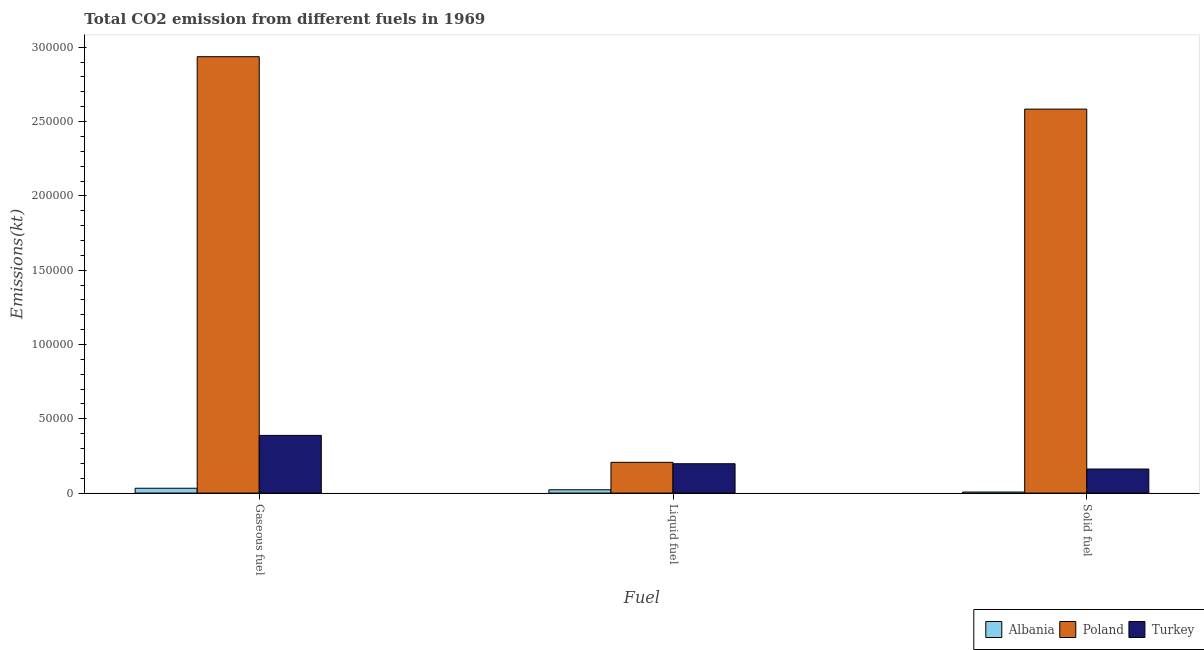Are the number of bars on each tick of the X-axis equal?
Your response must be concise. Yes. What is the label of the 2nd group of bars from the left?
Provide a succinct answer. Liquid fuel. What is the amount of co2 emissions from liquid fuel in Albania?
Give a very brief answer. 2222.2. Across all countries, what is the maximum amount of co2 emissions from solid fuel?
Keep it short and to the point. 2.58e+05. Across all countries, what is the minimum amount of co2 emissions from gaseous fuel?
Your answer should be compact. 3245.3. In which country was the amount of co2 emissions from solid fuel minimum?
Give a very brief answer. Albania. What is the total amount of co2 emissions from gaseous fuel in the graph?
Provide a short and direct response. 3.36e+05. What is the difference between the amount of co2 emissions from liquid fuel in Albania and that in Turkey?
Offer a very short reply. -1.75e+04. What is the difference between the amount of co2 emissions from liquid fuel in Poland and the amount of co2 emissions from gaseous fuel in Turkey?
Your answer should be compact. -1.81e+04. What is the average amount of co2 emissions from gaseous fuel per country?
Your answer should be compact. 1.12e+05. What is the difference between the amount of co2 emissions from gaseous fuel and amount of co2 emissions from liquid fuel in Poland?
Ensure brevity in your answer.  2.73e+05. In how many countries, is the amount of co2 emissions from liquid fuel greater than 120000 kt?
Offer a very short reply. 0. What is the ratio of the amount of co2 emissions from gaseous fuel in Poland to that in Turkey?
Provide a succinct answer. 7.57. Is the difference between the amount of co2 emissions from solid fuel in Albania and Poland greater than the difference between the amount of co2 emissions from liquid fuel in Albania and Poland?
Make the answer very short. No. What is the difference between the highest and the second highest amount of co2 emissions from gaseous fuel?
Your answer should be very brief. 2.55e+05. What is the difference between the highest and the lowest amount of co2 emissions from solid fuel?
Your answer should be compact. 2.58e+05. In how many countries, is the amount of co2 emissions from gaseous fuel greater than the average amount of co2 emissions from gaseous fuel taken over all countries?
Provide a short and direct response. 1. What does the 2nd bar from the left in Gaseous fuel represents?
Make the answer very short. Poland. What does the 3rd bar from the right in Solid fuel represents?
Offer a very short reply. Albania. Is it the case that in every country, the sum of the amount of co2 emissions from gaseous fuel and amount of co2 emissions from liquid fuel is greater than the amount of co2 emissions from solid fuel?
Make the answer very short. Yes. What is the difference between two consecutive major ticks on the Y-axis?
Offer a very short reply. 5.00e+04. Does the graph contain any zero values?
Your answer should be compact. No. How many legend labels are there?
Your answer should be very brief. 3. How are the legend labels stacked?
Make the answer very short. Horizontal. What is the title of the graph?
Ensure brevity in your answer.  Total CO2 emission from different fuels in 1969. What is the label or title of the X-axis?
Ensure brevity in your answer.  Fuel. What is the label or title of the Y-axis?
Give a very brief answer. Emissions(kt). What is the Emissions(kt) of Albania in Gaseous fuel?
Offer a terse response. 3245.3. What is the Emissions(kt) in Poland in Gaseous fuel?
Offer a terse response. 2.94e+05. What is the Emissions(kt) of Turkey in Gaseous fuel?
Ensure brevity in your answer.  3.88e+04. What is the Emissions(kt) of Albania in Liquid fuel?
Your response must be concise. 2222.2. What is the Emissions(kt) of Poland in Liquid fuel?
Offer a very short reply. 2.07e+04. What is the Emissions(kt) in Turkey in Liquid fuel?
Ensure brevity in your answer.  1.97e+04. What is the Emissions(kt) of Albania in Solid fuel?
Offer a very short reply. 689.4. What is the Emissions(kt) of Poland in Solid fuel?
Provide a succinct answer. 2.58e+05. What is the Emissions(kt) of Turkey in Solid fuel?
Your response must be concise. 1.62e+04. Across all Fuel, what is the maximum Emissions(kt) in Albania?
Ensure brevity in your answer.  3245.3. Across all Fuel, what is the maximum Emissions(kt) of Poland?
Your answer should be very brief. 2.94e+05. Across all Fuel, what is the maximum Emissions(kt) of Turkey?
Ensure brevity in your answer.  3.88e+04. Across all Fuel, what is the minimum Emissions(kt) in Albania?
Provide a succinct answer. 689.4. Across all Fuel, what is the minimum Emissions(kt) in Poland?
Keep it short and to the point. 2.07e+04. Across all Fuel, what is the minimum Emissions(kt) in Turkey?
Provide a succinct answer. 1.62e+04. What is the total Emissions(kt) of Albania in the graph?
Your answer should be compact. 6156.89. What is the total Emissions(kt) of Poland in the graph?
Your answer should be very brief. 5.73e+05. What is the total Emissions(kt) in Turkey in the graph?
Offer a terse response. 7.47e+04. What is the difference between the Emissions(kt) of Albania in Gaseous fuel and that in Liquid fuel?
Offer a very short reply. 1023.09. What is the difference between the Emissions(kt) of Poland in Gaseous fuel and that in Liquid fuel?
Provide a short and direct response. 2.73e+05. What is the difference between the Emissions(kt) of Turkey in Gaseous fuel and that in Liquid fuel?
Your answer should be very brief. 1.91e+04. What is the difference between the Emissions(kt) in Albania in Gaseous fuel and that in Solid fuel?
Keep it short and to the point. 2555.9. What is the difference between the Emissions(kt) of Poland in Gaseous fuel and that in Solid fuel?
Give a very brief answer. 3.53e+04. What is the difference between the Emissions(kt) in Turkey in Gaseous fuel and that in Solid fuel?
Offer a very short reply. 2.26e+04. What is the difference between the Emissions(kt) in Albania in Liquid fuel and that in Solid fuel?
Provide a short and direct response. 1532.81. What is the difference between the Emissions(kt) in Poland in Liquid fuel and that in Solid fuel?
Make the answer very short. -2.38e+05. What is the difference between the Emissions(kt) in Turkey in Liquid fuel and that in Solid fuel?
Give a very brief answer. 3564.32. What is the difference between the Emissions(kt) in Albania in Gaseous fuel and the Emissions(kt) in Poland in Liquid fuel?
Your answer should be compact. -1.74e+04. What is the difference between the Emissions(kt) of Albania in Gaseous fuel and the Emissions(kt) of Turkey in Liquid fuel?
Provide a short and direct response. -1.65e+04. What is the difference between the Emissions(kt) in Poland in Gaseous fuel and the Emissions(kt) in Turkey in Liquid fuel?
Offer a very short reply. 2.74e+05. What is the difference between the Emissions(kt) of Albania in Gaseous fuel and the Emissions(kt) of Poland in Solid fuel?
Your answer should be compact. -2.55e+05. What is the difference between the Emissions(kt) of Albania in Gaseous fuel and the Emissions(kt) of Turkey in Solid fuel?
Your answer should be compact. -1.29e+04. What is the difference between the Emissions(kt) in Poland in Gaseous fuel and the Emissions(kt) in Turkey in Solid fuel?
Your response must be concise. 2.77e+05. What is the difference between the Emissions(kt) of Albania in Liquid fuel and the Emissions(kt) of Poland in Solid fuel?
Make the answer very short. -2.56e+05. What is the difference between the Emissions(kt) in Albania in Liquid fuel and the Emissions(kt) in Turkey in Solid fuel?
Provide a short and direct response. -1.40e+04. What is the difference between the Emissions(kt) of Poland in Liquid fuel and the Emissions(kt) of Turkey in Solid fuel?
Your answer should be very brief. 4510.41. What is the average Emissions(kt) in Albania per Fuel?
Offer a very short reply. 2052.3. What is the average Emissions(kt) of Poland per Fuel?
Provide a succinct answer. 1.91e+05. What is the average Emissions(kt) of Turkey per Fuel?
Ensure brevity in your answer.  2.49e+04. What is the difference between the Emissions(kt) in Albania and Emissions(kt) in Poland in Gaseous fuel?
Ensure brevity in your answer.  -2.90e+05. What is the difference between the Emissions(kt) in Albania and Emissions(kt) in Turkey in Gaseous fuel?
Provide a short and direct response. -3.56e+04. What is the difference between the Emissions(kt) of Poland and Emissions(kt) of Turkey in Gaseous fuel?
Ensure brevity in your answer.  2.55e+05. What is the difference between the Emissions(kt) of Albania and Emissions(kt) of Poland in Liquid fuel?
Your response must be concise. -1.85e+04. What is the difference between the Emissions(kt) in Albania and Emissions(kt) in Turkey in Liquid fuel?
Give a very brief answer. -1.75e+04. What is the difference between the Emissions(kt) in Poland and Emissions(kt) in Turkey in Liquid fuel?
Provide a short and direct response. 946.09. What is the difference between the Emissions(kt) of Albania and Emissions(kt) of Poland in Solid fuel?
Provide a short and direct response. -2.58e+05. What is the difference between the Emissions(kt) of Albania and Emissions(kt) of Turkey in Solid fuel?
Offer a very short reply. -1.55e+04. What is the difference between the Emissions(kt) of Poland and Emissions(kt) of Turkey in Solid fuel?
Offer a very short reply. 2.42e+05. What is the ratio of the Emissions(kt) in Albania in Gaseous fuel to that in Liquid fuel?
Keep it short and to the point. 1.46. What is the ratio of the Emissions(kt) of Poland in Gaseous fuel to that in Liquid fuel?
Your answer should be compact. 14.19. What is the ratio of the Emissions(kt) in Turkey in Gaseous fuel to that in Liquid fuel?
Offer a very short reply. 1.97. What is the ratio of the Emissions(kt) of Albania in Gaseous fuel to that in Solid fuel?
Provide a succinct answer. 4.71. What is the ratio of the Emissions(kt) in Poland in Gaseous fuel to that in Solid fuel?
Provide a short and direct response. 1.14. What is the ratio of the Emissions(kt) in Turkey in Gaseous fuel to that in Solid fuel?
Provide a succinct answer. 2.4. What is the ratio of the Emissions(kt) in Albania in Liquid fuel to that in Solid fuel?
Your answer should be very brief. 3.22. What is the ratio of the Emissions(kt) of Poland in Liquid fuel to that in Solid fuel?
Provide a succinct answer. 0.08. What is the ratio of the Emissions(kt) in Turkey in Liquid fuel to that in Solid fuel?
Your answer should be very brief. 1.22. What is the difference between the highest and the second highest Emissions(kt) of Albania?
Keep it short and to the point. 1023.09. What is the difference between the highest and the second highest Emissions(kt) of Poland?
Offer a terse response. 3.53e+04. What is the difference between the highest and the second highest Emissions(kt) of Turkey?
Offer a very short reply. 1.91e+04. What is the difference between the highest and the lowest Emissions(kt) in Albania?
Make the answer very short. 2555.9. What is the difference between the highest and the lowest Emissions(kt) in Poland?
Make the answer very short. 2.73e+05. What is the difference between the highest and the lowest Emissions(kt) in Turkey?
Offer a terse response. 2.26e+04. 